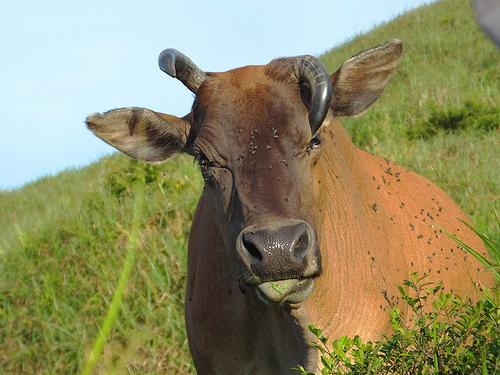What is the main activity the animal is doing in the image? The main activity the animal is doing is standing on a grassy hill. What is the dominant color of the animal in the image? The dominant color of the animal is brown. How is the animal attempting to consume food based on the appearance of its mouth? The animal is chewing food with its tongue sticking out, as there is grass on the tongue. Identify the type of animal in the image and the condition of its horns. The animal is a bull with one normal horn and another horn growing back into its head. Explain the unusual growth of one of the animal's horns. One of the bull's horns is growing back into its head, causing it to curve toward the eye instead of pointing up or out. Mention the type and location of the animal's body part that hosts insects. The flies are present on the bull's face and body. Explain the ongoing interaction between the animal's tongue and a surrounding object. The bull's large green tongue is sticking out and has grass on it, as if it is eating or tasting the grass. Assess the quality of the landscape in the image. The landscape is a bright sunny day with grass covering the hillside. What kind of plant appears in front of the bull? There is a green shrub or bush in front of the bull. Determine the sentiment or emotion evoked by the image. The image evokes a sense of empathy for the bull with the horn growing into its eye and a peaceful aura from the grassy landscape. Is the cow sticking out its tongue, and if so, what color is it? Yes, the cow is sticking out its tongue, and it is grey. Identify the boundaries of the grassy hill where the cow is standing. Grassy hill X:7 Y:11 Width:490 Height:490. What is the quality of the image? The image has a high quality with clear and detailed objects and captions. Discuss the anomalous object in the image and describe how it poses a threat. The anomalous object is the horn growing back into the cow's head, posing a threat to its eye and overall well-being. Highlight the differences between the two horns on the cow's head. One horn is normal, while the other is curved, growing back into the cow's head and causing a hazard to its eye. What is the state of the cow's snout? The cow's snout is wet. Describe the interaction between the cow and the greenery. The cow is eating from a green shrub in front of it, and some grass from the shrub is on its tongue. What type of hill is the cow standing on? A grassy hill. Map out the locations of the flies on the cow's body. Flies on the face X:232 Y:122 Width:68 Height:68, body X:369 Y:153 Width:99 Height:99, and eye X:187 Y:142 Width:39 Height:39. Is the cow seated or standing in the image? Provide the dimensions of the cow. The cow is standing. Dimensions: X:87 Y:43 Width:410 Height:410. Describe the setting of the image. A brown cow with unusual horns is standing on a grassy hill on a bright sunny day. There are flies all around it and the cow seems to be eating from a green shrub. Distinguish the colors and orientations of the cow's horns. One black horn is facing down, and another black horn facing up is curving back into the cow's face. Please provide a sentimental analysis of the scene depicted in the image. Mixed emotions; the scene has a positive aspect with the bright sunny day and the cow grazing, but the flies around the cow and its unusual horn evoke negative feelings. How would you describe the overall scene in the image? A brown cow with an unusual horn is standing on a grassy hill on a bright sunny day, surrounded by flies and eating from a green shrub. What color is the cow in the image and what type of insects are surrounding it? The cow is brown and it is surrounded by flies. Determine the parts of the brown cow. Body X:169 Y:128 Width:309 Height:309, mouth X:248 Y:271 Width:70 Height:70, normal horn X:158 Y:45 Width:59 Height:59, unusual horn X:264 Y:41 Width:70 Height:70, nostrils X:235 Y:223 Width:80 Height:80, ears X:87 Y:35 Width:316 Height:316. Identify the component of the cow that is growing incorrectly. One of the cow's horns is growing back into its head. Point out the objects associated with the bull's head. Normal horn X:158 Y:45 Width:59 Height:59, messed up horn X:264 Y:41 Width:70 Height:70, eye X:294 Y:113 Width:40 Height:40, flies X:236 Y:115 Width:60 Height:60, nose X:237 Y:225 Width:81 Height:81, mouth X:248 Y:271 Width:70 Height:70. 